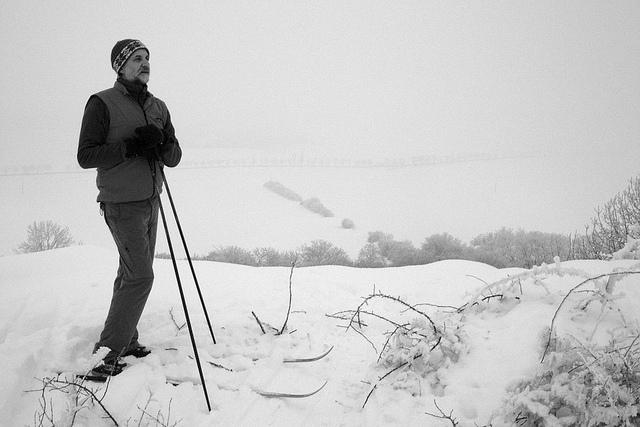Is this considered a heavy snow area?
Concise answer only. Yes. Is the snow deep?
Write a very short answer. Yes. Is this a good place to practice yoga?
Concise answer only. No. Which direction is this man likely to snowboard?
Give a very brief answer. Downhill. Is this a residential backyard?
Be succinct. No. 